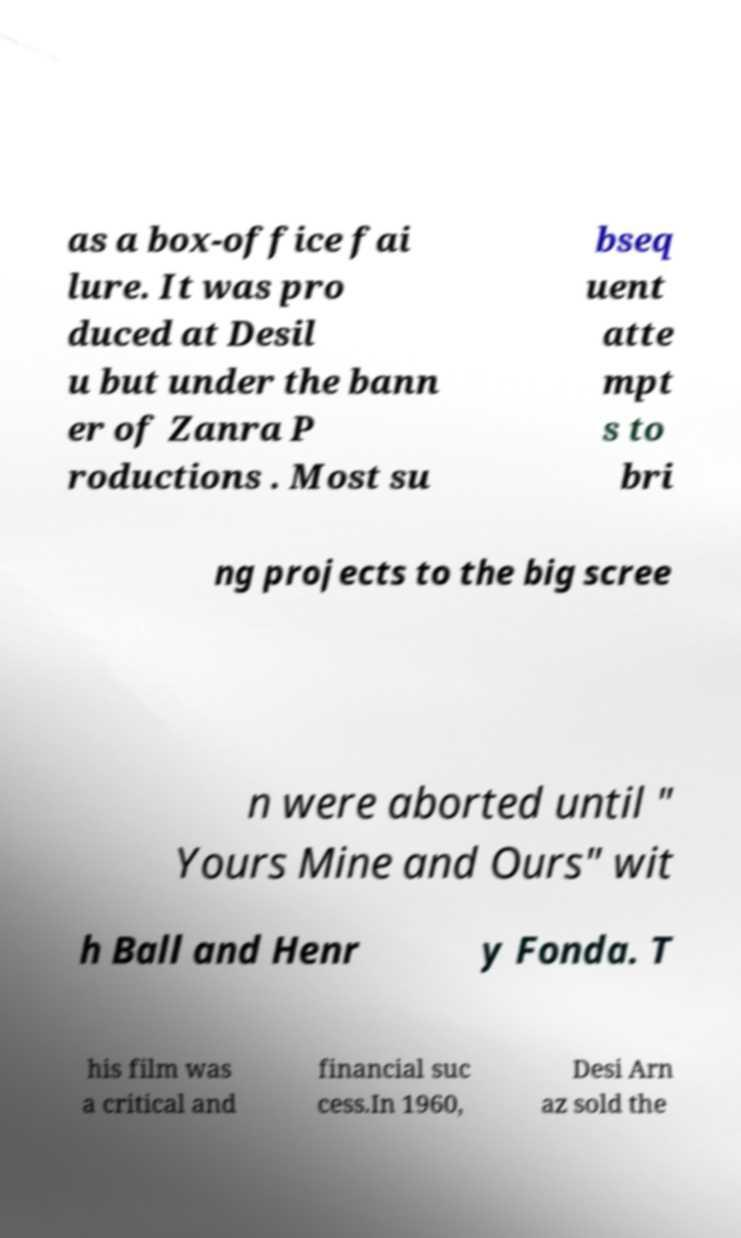Can you read and provide the text displayed in the image?This photo seems to have some interesting text. Can you extract and type it out for me? as a box-office fai lure. It was pro duced at Desil u but under the bann er of Zanra P roductions . Most su bseq uent atte mpt s to bri ng projects to the big scree n were aborted until " Yours Mine and Ours" wit h Ball and Henr y Fonda. T his film was a critical and financial suc cess.In 1960, Desi Arn az sold the 